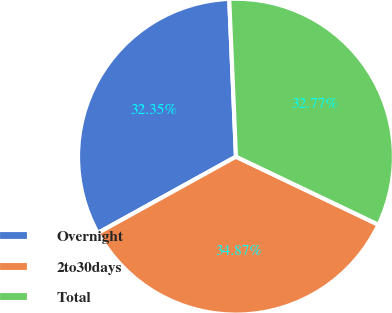<chart> <loc_0><loc_0><loc_500><loc_500><pie_chart><fcel>Overnight<fcel>2to30days<fcel>Total<nl><fcel>32.35%<fcel>34.87%<fcel>32.77%<nl></chart> 